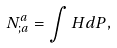Convert formula to latex. <formula><loc_0><loc_0><loc_500><loc_500>N ^ { a } _ { ; a } = \int H d P ,</formula> 